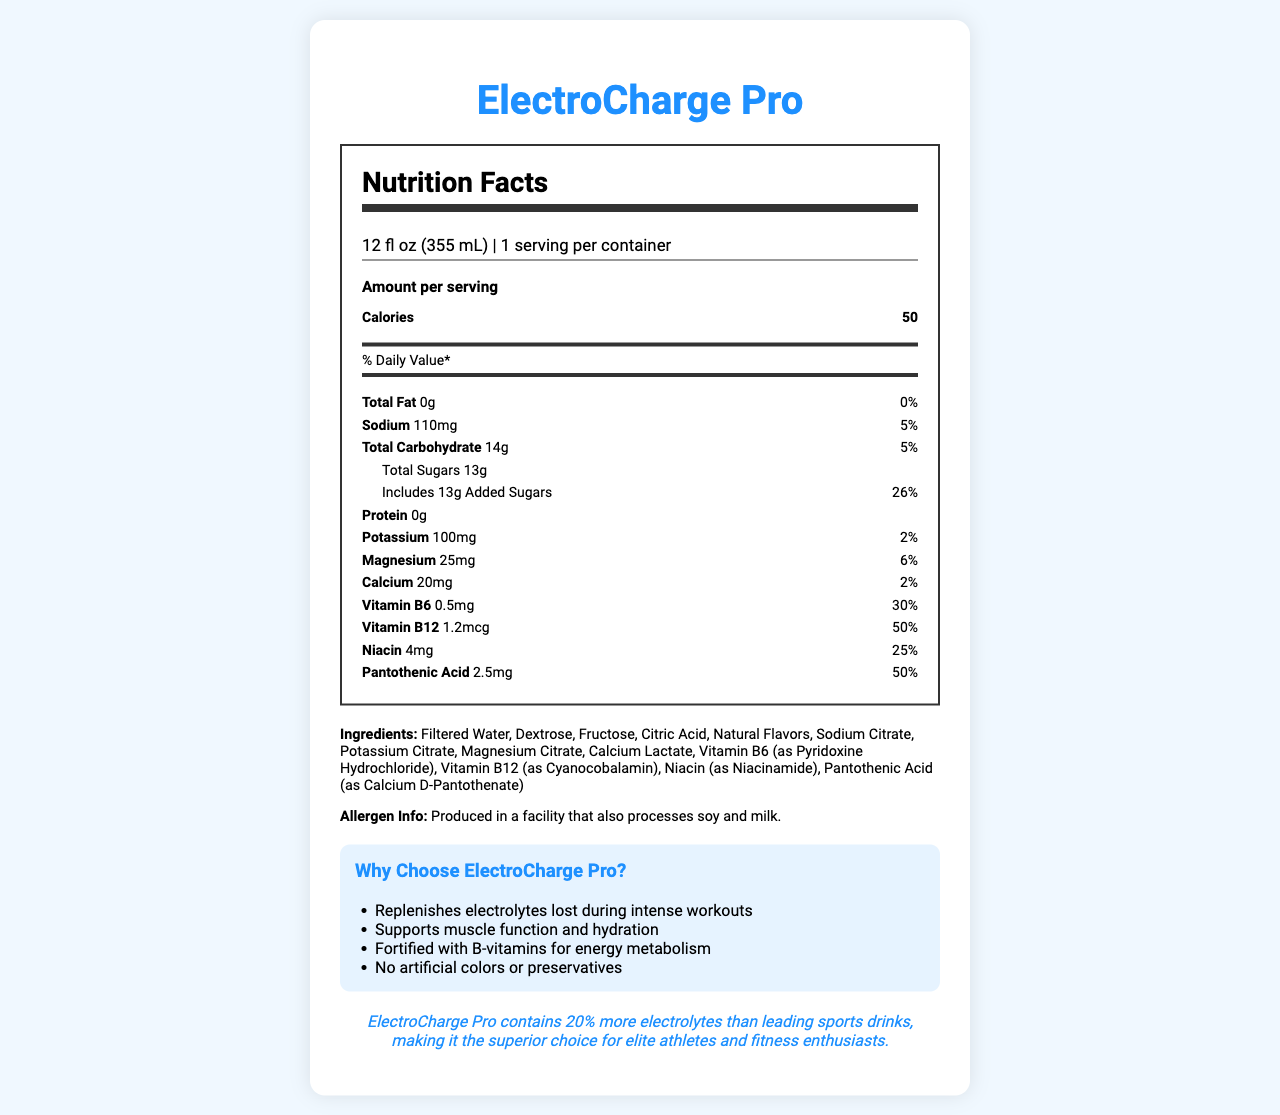what is the serving size of ElectroCharge Pro? The serving size is stated at the top of the Nutrition Facts label as 12 fl oz (355 mL).
Answer: 12 fl oz (355 mL) how many calories are in one serving of ElectroCharge Pro? The number of calories per serving is listed as 50 under the "Amount per serving" section.
Answer: 50 what percentage of the daily value of sodium does one serving contain? The sodium content is listed on the Nutrition Facts label as 110mg, which is 5% of the daily value.
Answer: 5% what ingredients are used in ElectroCharge Pro? The ingredients are listed near the bottom of the document under "Ingredients".
Answer: Filtered Water, Dextrose, Fructose, Citric Acid, Natural Flavors, Sodium Citrate, Potassium Citrate, Magnesium Citrate, Calcium Lactate, Vitamin B6 (as Pyridoxine Hydrochloride), Vitamin B12 (as Cyanocobalamin), Niacin (as Niacinamide), Pantothenic Acid (as Calcium D-Pantothenate) what is the total carbohydrate content in one serving? The total carbohydrate content per serving is listed as 14g in the Nutrition Facts label.
Answer: 14g what is the percentage of the daily value for added sugars in ElectroCharge Pro? A. 5% B. 10% C. 20% D. 26% The daily value of added sugars is 26%, as shown under the "Includes 13g Added Sugars" section.
Answer: D. 26% which vitamin has the highest percentage of daily value in ElectroCharge Pro? A. Vitamin B6 B. Vitamin B12 C. Niacin D. Pantothenic Acid Vitamin B12 has a daily value of 50%, which is the highest among the listed vitamins.
Answer: B. Vitamin B12 does ElectroCharge Pro contain any artificial colors or preservatives? According to the marketing claims, ElectroCharge Pro contains no artificial colors or preservatives.
Answer: No does ElectroCharge Pro help with hydration? One of the marketing claims states that ElectroCharge Pro supports muscle function and hydration.
Answer: Yes give a brief summary of the ElectroCharge Pro document. The document details the nutritional information, ingredients, allergen information, and several marketing claims for the ElectroCharge Pro sports drink.
Answer: ElectroCharge Pro is a sports drink designed to replenish electrolytes and support hydration. It contains 50 calories per serving and a variety of vitamins and minerals including Vitamin B6, B12, niacin, and pantothenic acid. The product is free from artificial colors and preservatives and is especially fortified with electrolytes such as potassium, magnesium, and calcium. It claims to be superior to leading sports drinks by having 20% more electrolytes. does ElectroCharge Pro contain allergens? The document states it is produced in a facility that also processes soy and milk, but it does not specify whether it contains these allergens.
Answer: Not enough information 